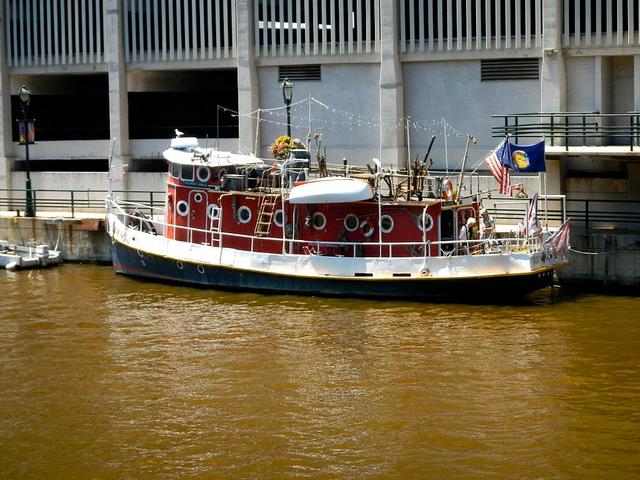How many people are on the boat?
Answer briefly. 2. Is there a flag on the boat?
Write a very short answer. Yes. What color is the water?
Give a very brief answer. Brown. 